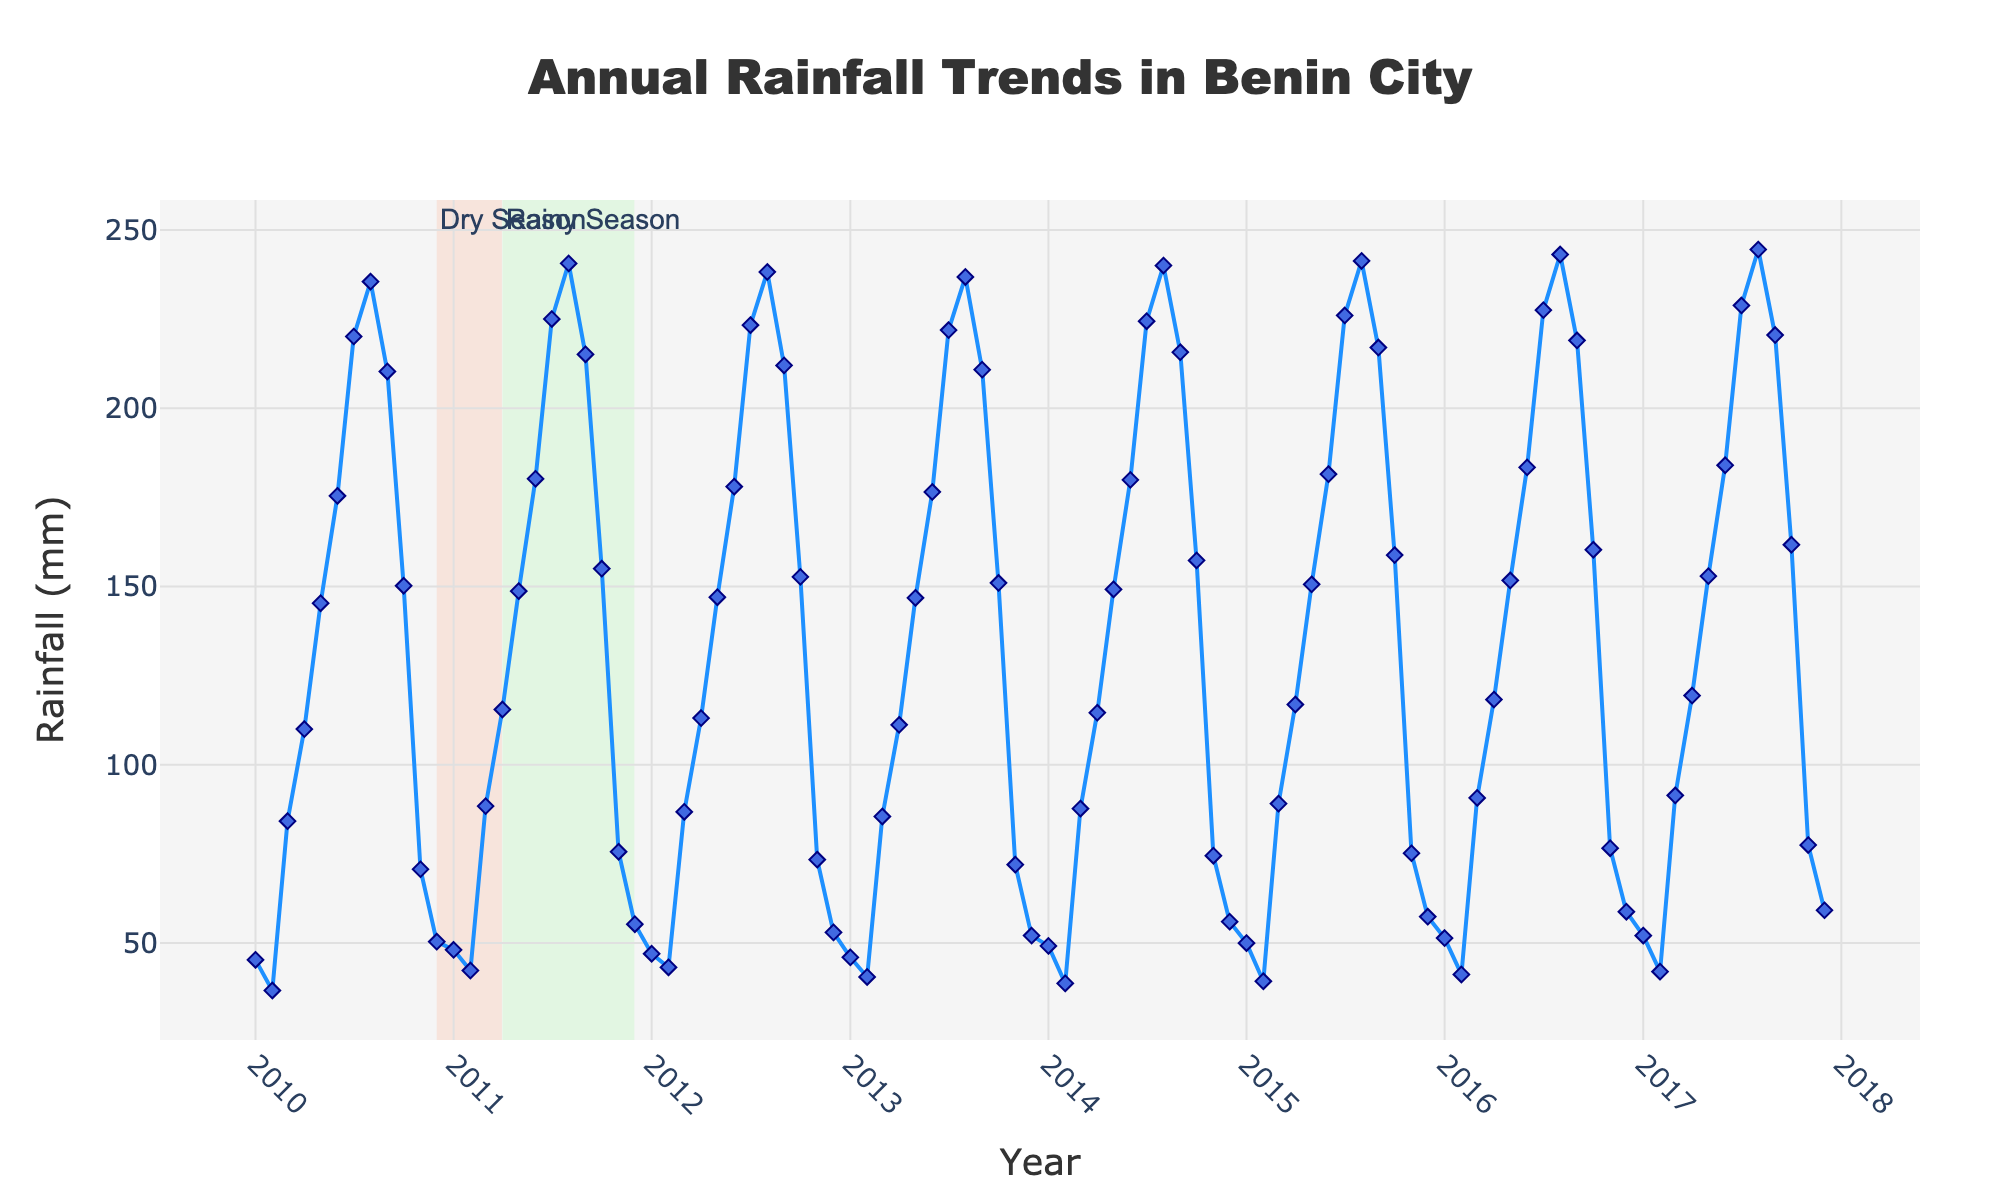What is the title of the figure? The title is displayed at the top center of the figure. It summarizes the main theme or purpose of the plot.
Answer: Annual Rainfall Trends in Benin City Which month and year had the highest recorded rainfall? By examining the y-axis for the highest point on the line and checking the corresponding x-axis label for month and year, we can identify the highest recorded rainfall.
Answer: August 2017 What does the x-axis represent? The x-axis, which is labeled "Year," represents time. Each tick mark and label corresponds to a specific month and year combination.
Answer: Year How does the rainfall vary between January and July? By looking at the data points from January to July for each year, we can see that the rainfall generally increases, reaching a peak around July.
Answer: Generally increases Which season is represented by the shaded area from December to March? The shaded area from December to March is annotated on the plot as the "Dry Season," with the appropriate color coding.
Answer: Dry Season What is the overall trend in the annual rainfall over the years? The overall trend can be observed by following the line plot from the beginning to end. It appears to increase until August and then slightly decrease.
Answer: Increasing until August then decreasing How does the average rainfall in the rainy season compare to the dry season? By calculating the average rainfall for the months April to November (rainy season) and December to March (dry season) and comparing the two averages, we can see that the rainy season has higher average rainfall.
Answer: Higher in the rainy season Which year showed the lowest rainfall in February? By checking the February data points for each year and identifying the minimum value, we find the year with the lowest rainfall.
Answer: 2015 Is the rainfall in October typically higher or lower than in November? By comparing the data points for October and November across different years, October consistently shows higher rainfall than November.
Answer: Higher in October What is the rainfall range (difference between maximum and minimum) in June across the years? To find the range, identify the maximum and minimum rainfall values for June from the plot, and calculate their difference.
Answer: 184.0 - 175.4 = 8.6 mm 